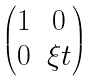<formula> <loc_0><loc_0><loc_500><loc_500>\begin{pmatrix} 1 & 0 \\ 0 & \xi t \end{pmatrix}</formula> 